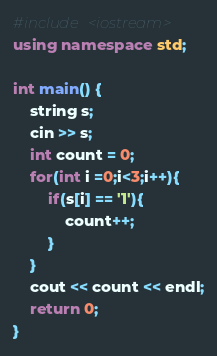Convert code to text. <code><loc_0><loc_0><loc_500><loc_500><_C++_>#include <iostream>
using namespace std;

int main() {
    string s;
    cin >> s;
    int count = 0;
    for(int i =0;i<3;i++){
        if(s[i] == '1'){
            count++;
        }
    }
    cout << count << endl;
    return 0;
}</code> 